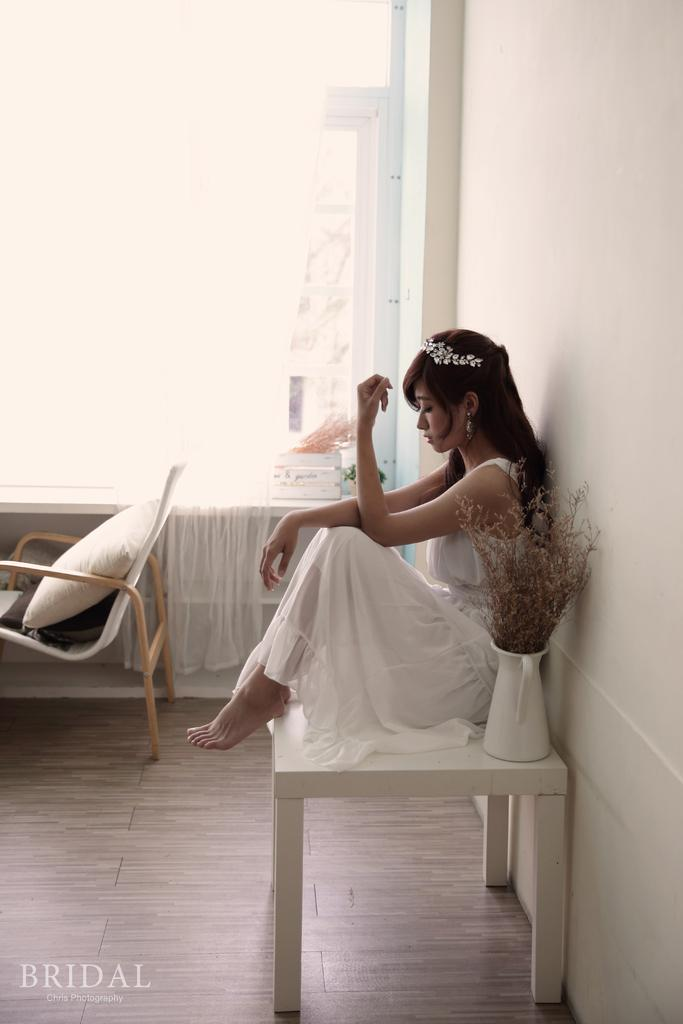Who is present in the image? There is a woman in the image. What is the woman doing in the image? The woman is sitting on a table. What can be seen in the background of the image? There is a wall visible in the image. What object is present in the image that might be used for comfort or support? There is a pillow in the image. What type of education does the bat in the image have? There is no bat present in the image, so it is not possible to determine its education. 